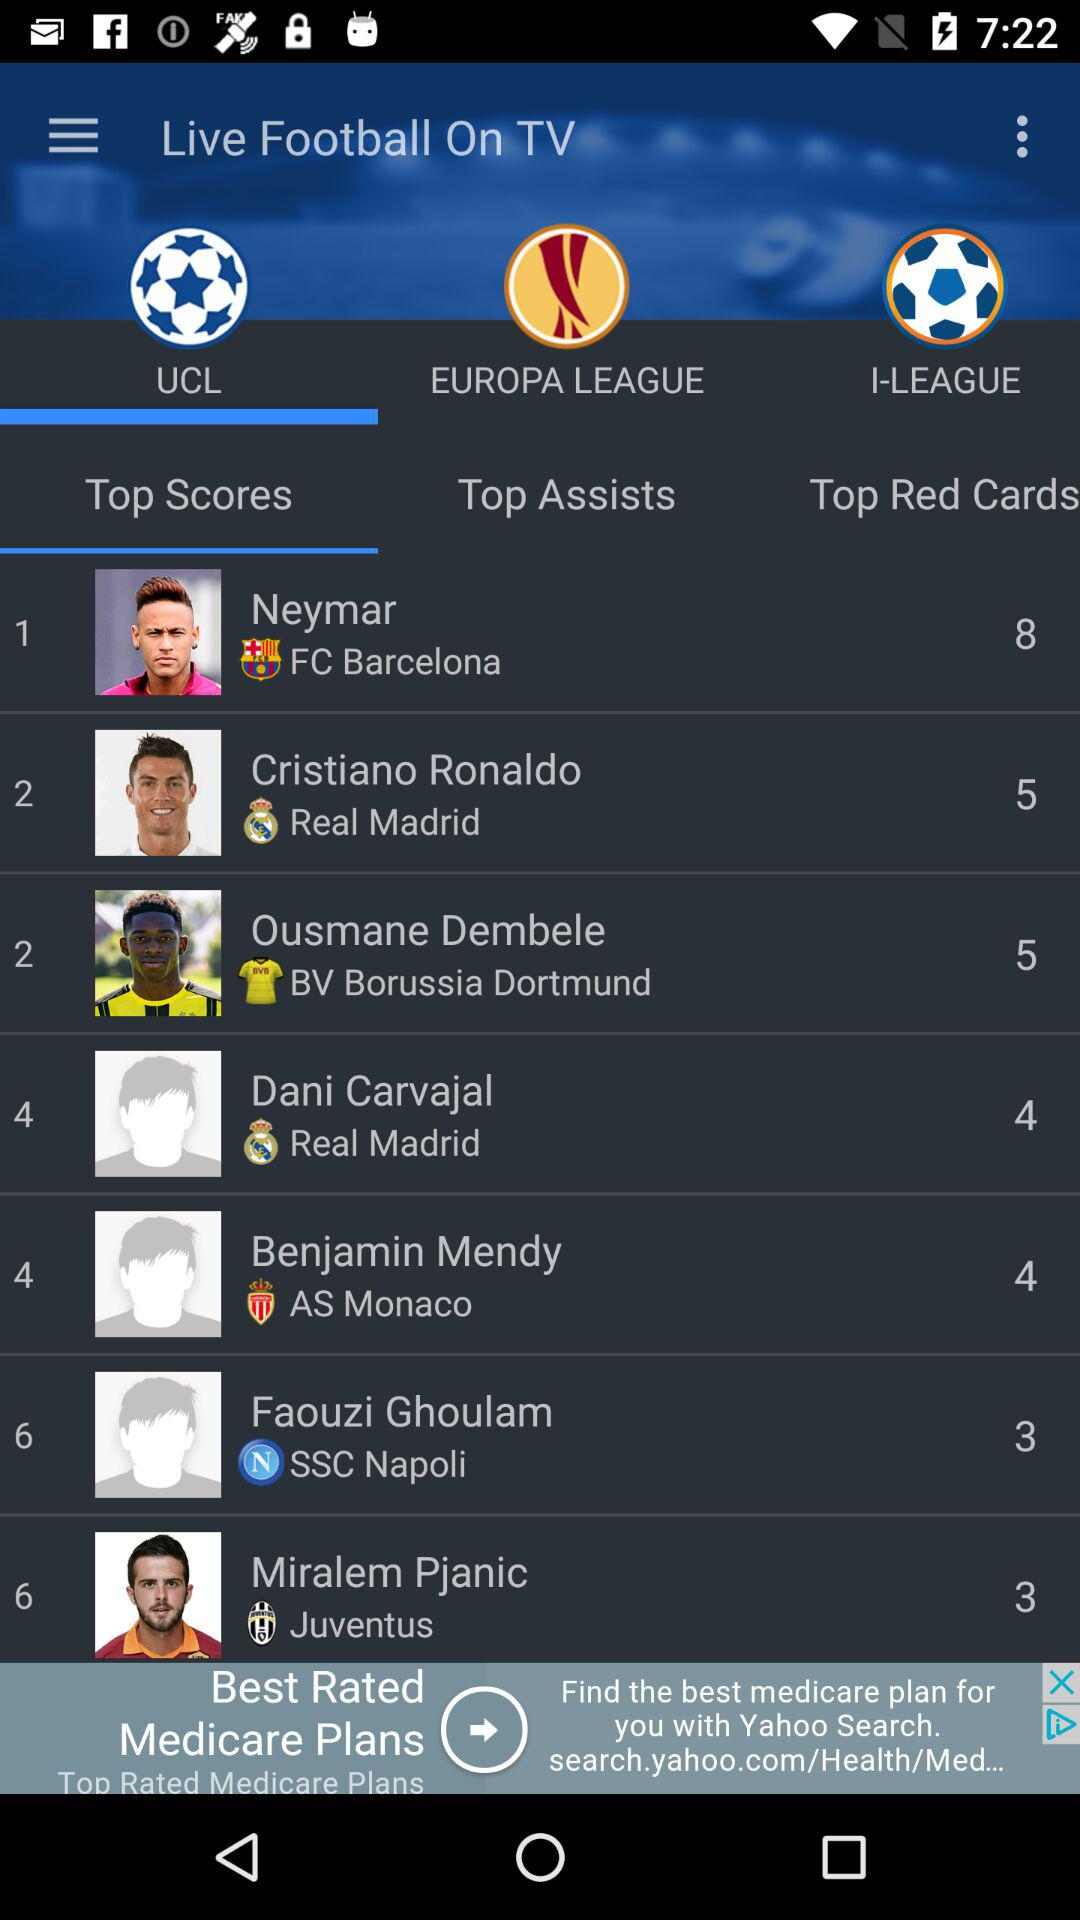Who is UCL's top scorer? UCL's top scorer is Neymar. 